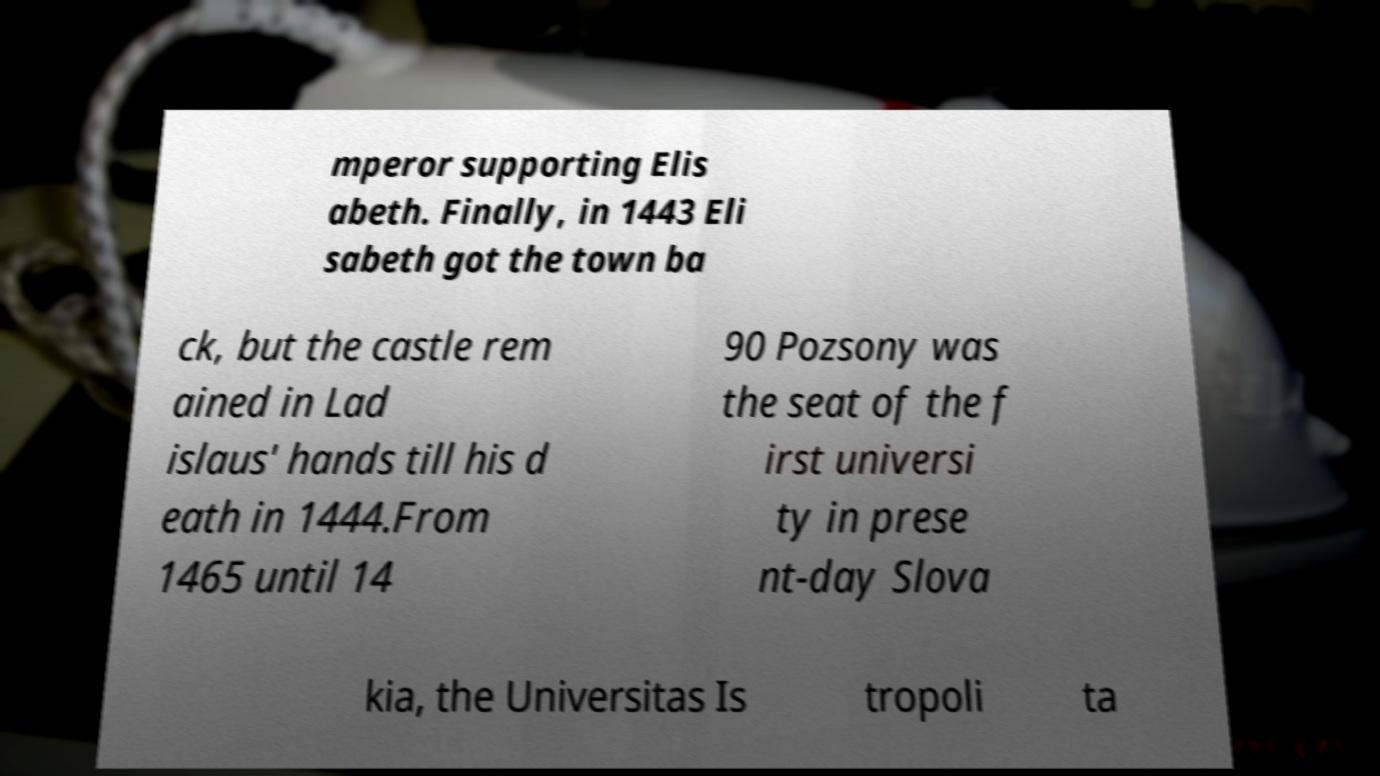Can you accurately transcribe the text from the provided image for me? mperor supporting Elis abeth. Finally, in 1443 Eli sabeth got the town ba ck, but the castle rem ained in Lad islaus' hands till his d eath in 1444.From 1465 until 14 90 Pozsony was the seat of the f irst universi ty in prese nt-day Slova kia, the Universitas Is tropoli ta 